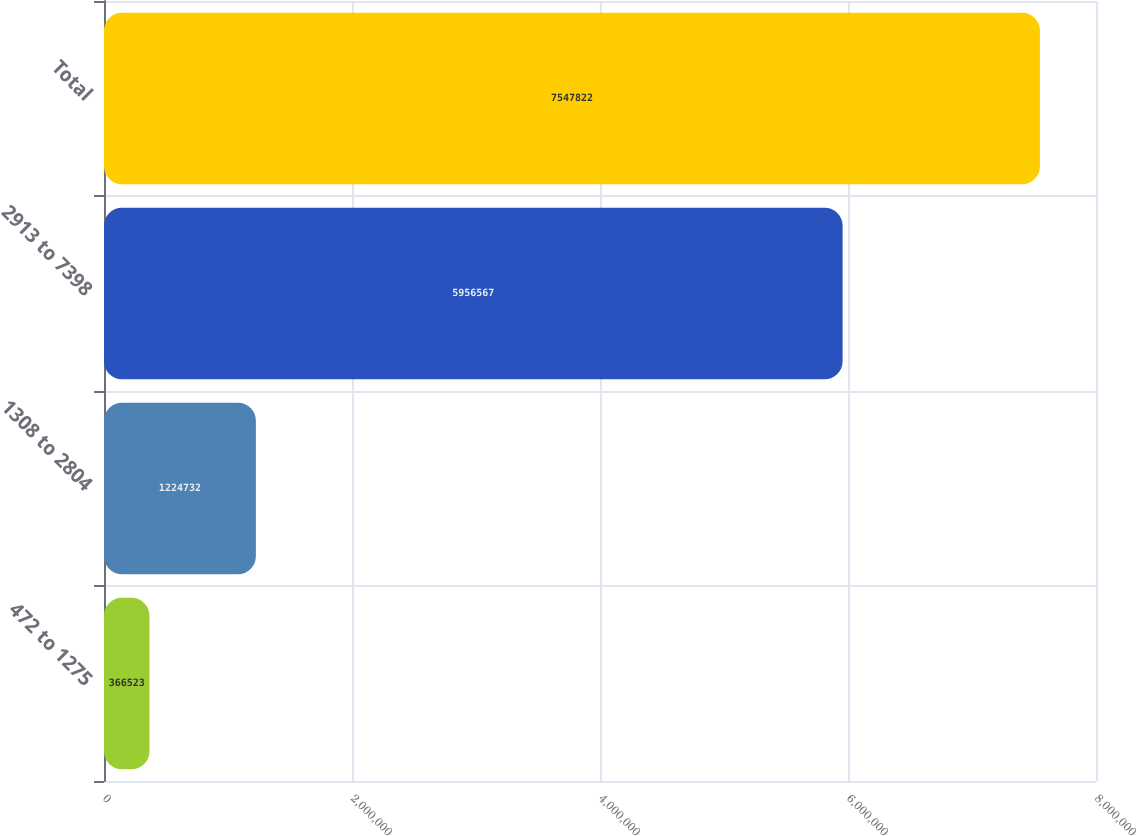Convert chart. <chart><loc_0><loc_0><loc_500><loc_500><bar_chart><fcel>472 to 1275<fcel>1308 to 2804<fcel>2913 to 7398<fcel>Total<nl><fcel>366523<fcel>1.22473e+06<fcel>5.95657e+06<fcel>7.54782e+06<nl></chart> 